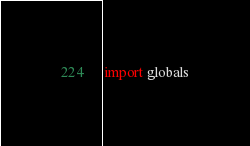<code> <loc_0><loc_0><loc_500><loc_500><_Python_>import globals
</code> 